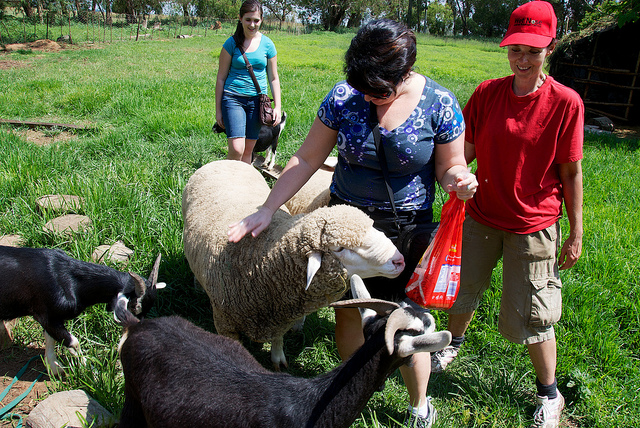Are there any other animals apart from the sheep and goats in the image? No, the only animals visible in the image are the sheep and goats. There are no other types of animals present in the scene. 